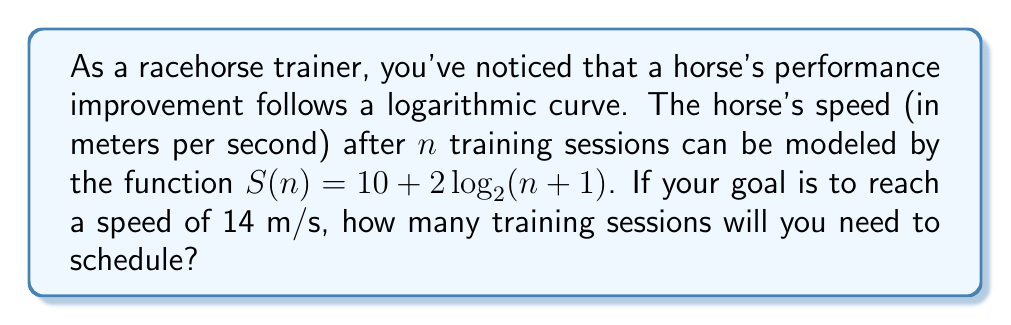Could you help me with this problem? To solve this problem, we need to use the given logarithmic function and solve for $n$. Here's the step-by-step process:

1) We want to find $n$ when $S(n) = 14$. So, we set up the equation:

   $14 = 10 + 2\log_2(n+1)$

2) Subtract 10 from both sides:

   $4 = 2\log_2(n+1)$

3) Divide both sides by 2:

   $2 = \log_2(n+1)$

4) To solve for $n$, we need to apply the inverse function (exponential) to both sides:

   $2^2 = 2^{\log_2(n+1)}$

5) Simplify the left side:

   $4 = n+1$

6) Subtract 1 from both sides:

   $3 = n$

7) Therefore, we need 3 training sessions to reach a speed of 14 m/s.

However, since we can only have whole numbers of training sessions, and the question asks for an estimate, we should round up to ensure we reach or exceed the target speed.
Answer: 4 training sessions 